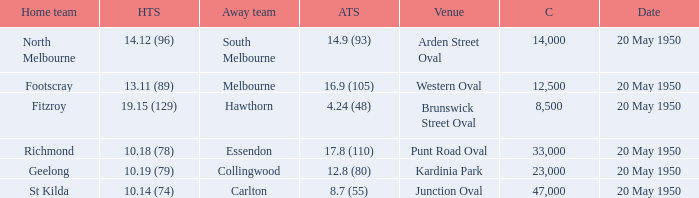What was the score for the away team when the home team was Fitzroy? 4.24 (48). 